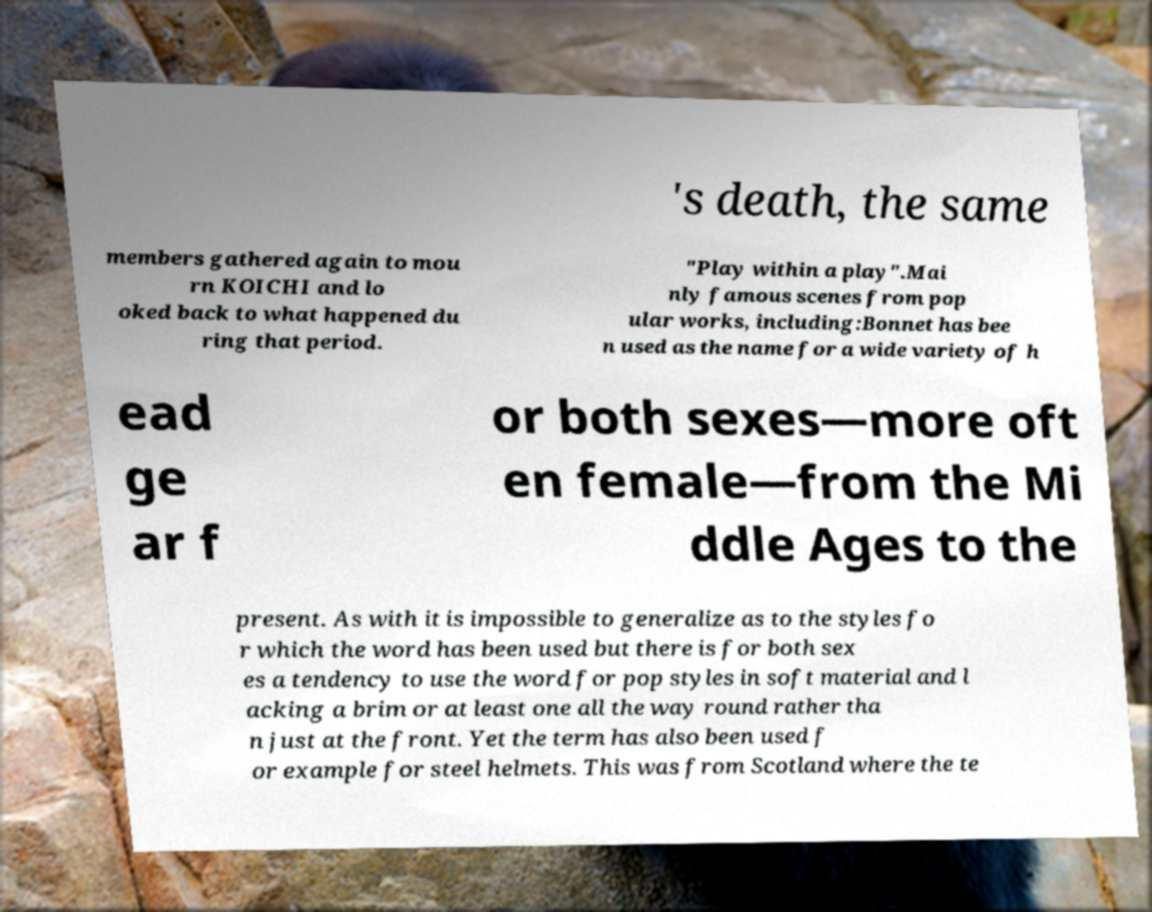Can you read and provide the text displayed in the image?This photo seems to have some interesting text. Can you extract and type it out for me? 's death, the same members gathered again to mou rn KOICHI and lo oked back to what happened du ring that period. "Play within a play".Mai nly famous scenes from pop ular works, including:Bonnet has bee n used as the name for a wide variety of h ead ge ar f or both sexes—more oft en female—from the Mi ddle Ages to the present. As with it is impossible to generalize as to the styles fo r which the word has been used but there is for both sex es a tendency to use the word for pop styles in soft material and l acking a brim or at least one all the way round rather tha n just at the front. Yet the term has also been used f or example for steel helmets. This was from Scotland where the te 